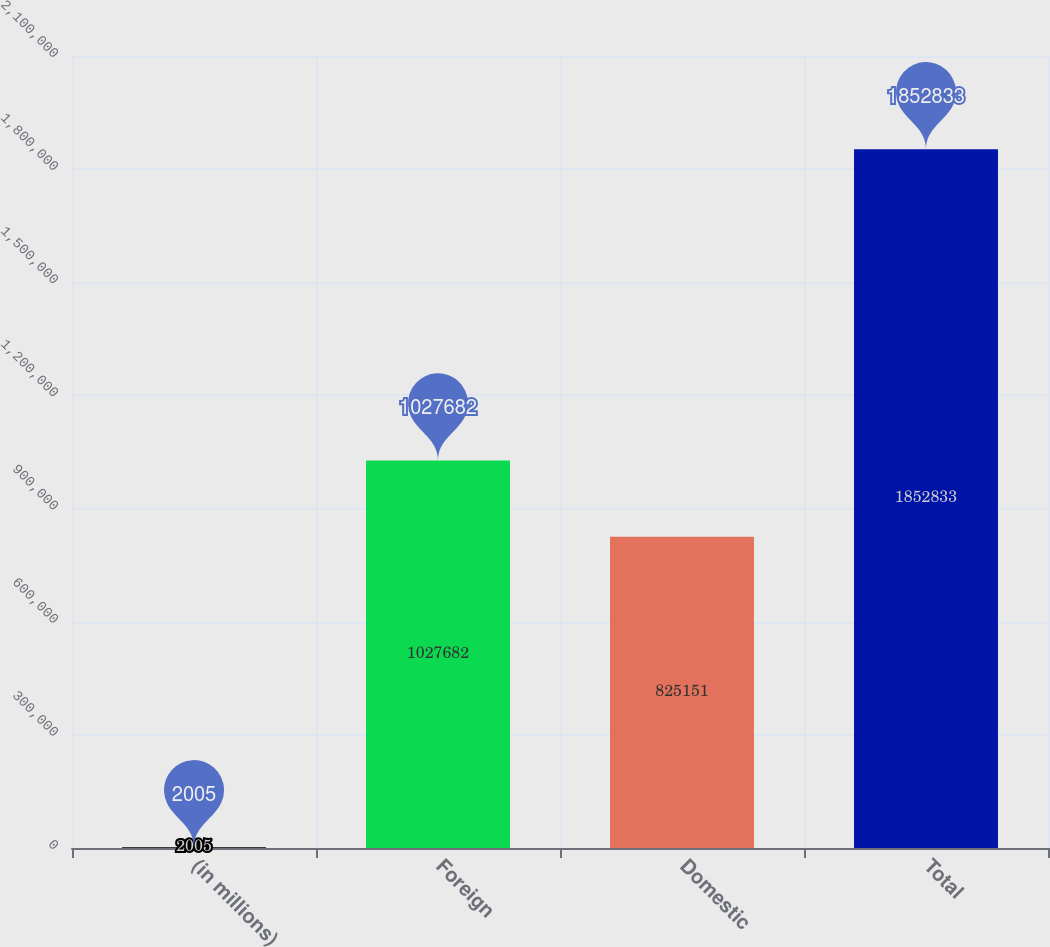Convert chart. <chart><loc_0><loc_0><loc_500><loc_500><bar_chart><fcel>(in millions)<fcel>Foreign<fcel>Domestic<fcel>Total<nl><fcel>2005<fcel>1.02768e+06<fcel>825151<fcel>1.85283e+06<nl></chart> 